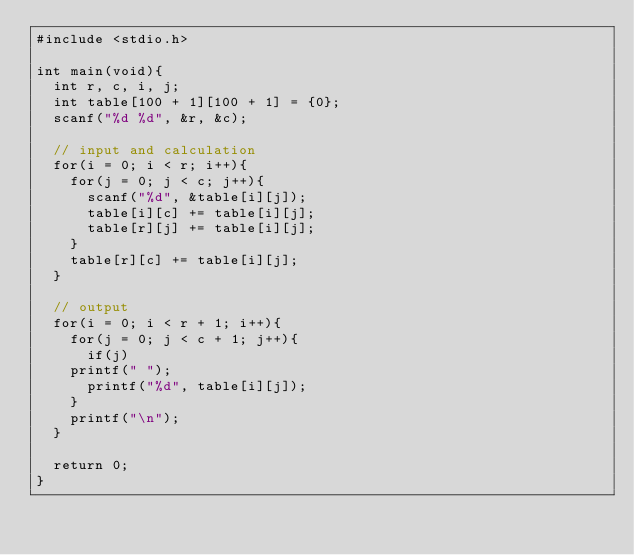Convert code to text. <code><loc_0><loc_0><loc_500><loc_500><_C_>#include <stdio.h>

int main(void){
  int r, c, i, j;
  int table[100 + 1][100 + 1] = {0};
  scanf("%d %d", &r, &c);

  // input and calculation
  for(i = 0; i < r; i++){
    for(j = 0; j < c; j++){
      scanf("%d", &table[i][j]);
      table[i][c] += table[i][j];
      table[r][j] += table[i][j];
    }
    table[r][c] += table[i][j];
  }
    
  // output
  for(i = 0; i < r + 1; i++){
    for(j = 0; j < c + 1; j++){
      if(j)
	printf(" ");
      printf("%d", table[i][j]);
    }
    printf("\n");
  }

  return 0;
}</code> 